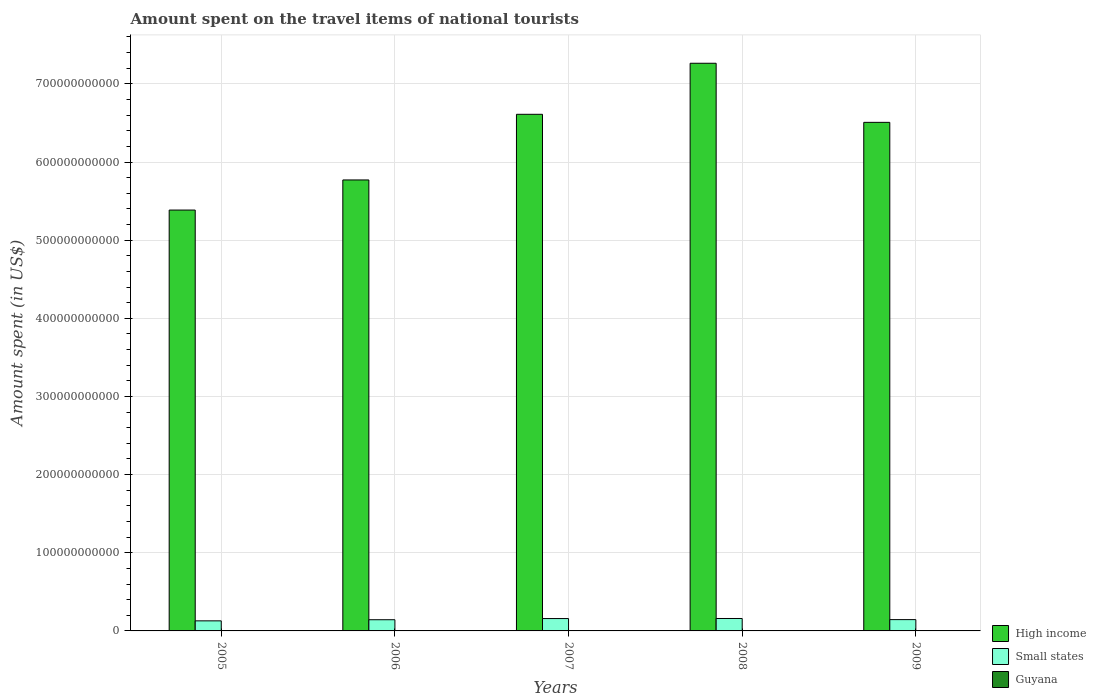How many different coloured bars are there?
Keep it short and to the point. 3. How many groups of bars are there?
Offer a terse response. 5. Are the number of bars per tick equal to the number of legend labels?
Your response must be concise. Yes. Are the number of bars on each tick of the X-axis equal?
Keep it short and to the point. Yes. How many bars are there on the 4th tick from the right?
Your response must be concise. 3. What is the amount spent on the travel items of national tourists in Guyana in 2009?
Offer a terse response. 3.50e+07. Across all years, what is the maximum amount spent on the travel items of national tourists in High income?
Offer a terse response. 7.26e+11. Across all years, what is the minimum amount spent on the travel items of national tourists in High income?
Ensure brevity in your answer.  5.39e+11. What is the total amount spent on the travel items of national tourists in High income in the graph?
Your answer should be very brief. 3.15e+12. What is the difference between the amount spent on the travel items of national tourists in Small states in 2007 and that in 2008?
Offer a very short reply. -7.92e+07. What is the difference between the amount spent on the travel items of national tourists in Small states in 2008 and the amount spent on the travel items of national tourists in Guyana in 2005?
Your response must be concise. 1.59e+1. What is the average amount spent on the travel items of national tourists in Small states per year?
Ensure brevity in your answer.  1.47e+1. In the year 2005, what is the difference between the amount spent on the travel items of national tourists in Small states and amount spent on the travel items of national tourists in Guyana?
Your answer should be very brief. 1.28e+1. What is the ratio of the amount spent on the travel items of national tourists in Guyana in 2005 to that in 2006?
Provide a succinct answer. 0.95. Is the difference between the amount spent on the travel items of national tourists in Small states in 2008 and 2009 greater than the difference between the amount spent on the travel items of national tourists in Guyana in 2008 and 2009?
Keep it short and to the point. Yes. What is the difference between the highest and the second highest amount spent on the travel items of national tourists in High income?
Your answer should be compact. 6.53e+1. What is the difference between the highest and the lowest amount spent on the travel items of national tourists in Guyana?
Your answer should be very brief. 2.40e+07. Is the sum of the amount spent on the travel items of national tourists in Small states in 2005 and 2008 greater than the maximum amount spent on the travel items of national tourists in High income across all years?
Offer a terse response. No. What does the 1st bar from the right in 2005 represents?
Keep it short and to the point. Guyana. How many bars are there?
Give a very brief answer. 15. What is the difference between two consecutive major ticks on the Y-axis?
Your response must be concise. 1.00e+11. Are the values on the major ticks of Y-axis written in scientific E-notation?
Provide a short and direct response. No. Does the graph contain grids?
Give a very brief answer. Yes. How many legend labels are there?
Your answer should be compact. 3. How are the legend labels stacked?
Give a very brief answer. Vertical. What is the title of the graph?
Make the answer very short. Amount spent on the travel items of national tourists. Does "Japan" appear as one of the legend labels in the graph?
Keep it short and to the point. No. What is the label or title of the Y-axis?
Provide a short and direct response. Amount spent (in US$). What is the Amount spent (in US$) in High income in 2005?
Make the answer very short. 5.39e+11. What is the Amount spent (in US$) in Small states in 2005?
Make the answer very short. 1.29e+1. What is the Amount spent (in US$) in Guyana in 2005?
Provide a succinct answer. 3.50e+07. What is the Amount spent (in US$) of High income in 2006?
Offer a terse response. 5.77e+11. What is the Amount spent (in US$) in Small states in 2006?
Your response must be concise. 1.43e+1. What is the Amount spent (in US$) of Guyana in 2006?
Provide a short and direct response. 3.70e+07. What is the Amount spent (in US$) in High income in 2007?
Offer a terse response. 6.61e+11. What is the Amount spent (in US$) of Small states in 2007?
Keep it short and to the point. 1.58e+1. What is the Amount spent (in US$) in High income in 2008?
Provide a short and direct response. 7.26e+11. What is the Amount spent (in US$) in Small states in 2008?
Provide a succinct answer. 1.59e+1. What is the Amount spent (in US$) in Guyana in 2008?
Your answer should be very brief. 5.90e+07. What is the Amount spent (in US$) in High income in 2009?
Your response must be concise. 6.51e+11. What is the Amount spent (in US$) of Small states in 2009?
Give a very brief answer. 1.45e+1. What is the Amount spent (in US$) in Guyana in 2009?
Offer a very short reply. 3.50e+07. Across all years, what is the maximum Amount spent (in US$) in High income?
Your response must be concise. 7.26e+11. Across all years, what is the maximum Amount spent (in US$) in Small states?
Give a very brief answer. 1.59e+1. Across all years, what is the maximum Amount spent (in US$) in Guyana?
Offer a terse response. 5.90e+07. Across all years, what is the minimum Amount spent (in US$) in High income?
Your answer should be compact. 5.39e+11. Across all years, what is the minimum Amount spent (in US$) in Small states?
Provide a succinct answer. 1.29e+1. Across all years, what is the minimum Amount spent (in US$) of Guyana?
Your answer should be very brief. 3.50e+07. What is the total Amount spent (in US$) in High income in the graph?
Offer a terse response. 3.15e+12. What is the total Amount spent (in US$) of Small states in the graph?
Your answer should be very brief. 7.34e+1. What is the total Amount spent (in US$) of Guyana in the graph?
Your answer should be very brief. 2.16e+08. What is the difference between the Amount spent (in US$) of High income in 2005 and that in 2006?
Your response must be concise. -3.85e+1. What is the difference between the Amount spent (in US$) of Small states in 2005 and that in 2006?
Give a very brief answer. -1.44e+09. What is the difference between the Amount spent (in US$) of High income in 2005 and that in 2007?
Your response must be concise. -1.23e+11. What is the difference between the Amount spent (in US$) in Small states in 2005 and that in 2007?
Offer a terse response. -2.95e+09. What is the difference between the Amount spent (in US$) in Guyana in 2005 and that in 2007?
Keep it short and to the point. -1.50e+07. What is the difference between the Amount spent (in US$) of High income in 2005 and that in 2008?
Your response must be concise. -1.88e+11. What is the difference between the Amount spent (in US$) in Small states in 2005 and that in 2008?
Provide a succinct answer. -3.02e+09. What is the difference between the Amount spent (in US$) of Guyana in 2005 and that in 2008?
Make the answer very short. -2.40e+07. What is the difference between the Amount spent (in US$) in High income in 2005 and that in 2009?
Your answer should be compact. -1.12e+11. What is the difference between the Amount spent (in US$) of Small states in 2005 and that in 2009?
Offer a terse response. -1.58e+09. What is the difference between the Amount spent (in US$) of High income in 2006 and that in 2007?
Your answer should be very brief. -8.40e+1. What is the difference between the Amount spent (in US$) of Small states in 2006 and that in 2007?
Make the answer very short. -1.51e+09. What is the difference between the Amount spent (in US$) in Guyana in 2006 and that in 2007?
Ensure brevity in your answer.  -1.30e+07. What is the difference between the Amount spent (in US$) in High income in 2006 and that in 2008?
Your answer should be very brief. -1.49e+11. What is the difference between the Amount spent (in US$) in Small states in 2006 and that in 2008?
Give a very brief answer. -1.59e+09. What is the difference between the Amount spent (in US$) of Guyana in 2006 and that in 2008?
Ensure brevity in your answer.  -2.20e+07. What is the difference between the Amount spent (in US$) of High income in 2006 and that in 2009?
Your answer should be compact. -7.37e+1. What is the difference between the Amount spent (in US$) in Small states in 2006 and that in 2009?
Make the answer very short. -1.39e+08. What is the difference between the Amount spent (in US$) in Guyana in 2006 and that in 2009?
Offer a very short reply. 2.00e+06. What is the difference between the Amount spent (in US$) in High income in 2007 and that in 2008?
Keep it short and to the point. -6.53e+1. What is the difference between the Amount spent (in US$) in Small states in 2007 and that in 2008?
Provide a succinct answer. -7.92e+07. What is the difference between the Amount spent (in US$) of Guyana in 2007 and that in 2008?
Your answer should be very brief. -9.00e+06. What is the difference between the Amount spent (in US$) of High income in 2007 and that in 2009?
Keep it short and to the point. 1.03e+1. What is the difference between the Amount spent (in US$) in Small states in 2007 and that in 2009?
Your response must be concise. 1.37e+09. What is the difference between the Amount spent (in US$) of Guyana in 2007 and that in 2009?
Your answer should be very brief. 1.50e+07. What is the difference between the Amount spent (in US$) of High income in 2008 and that in 2009?
Offer a terse response. 7.56e+1. What is the difference between the Amount spent (in US$) in Small states in 2008 and that in 2009?
Offer a very short reply. 1.45e+09. What is the difference between the Amount spent (in US$) of Guyana in 2008 and that in 2009?
Provide a short and direct response. 2.40e+07. What is the difference between the Amount spent (in US$) in High income in 2005 and the Amount spent (in US$) in Small states in 2006?
Make the answer very short. 5.24e+11. What is the difference between the Amount spent (in US$) in High income in 2005 and the Amount spent (in US$) in Guyana in 2006?
Offer a terse response. 5.39e+11. What is the difference between the Amount spent (in US$) of Small states in 2005 and the Amount spent (in US$) of Guyana in 2006?
Give a very brief answer. 1.28e+1. What is the difference between the Amount spent (in US$) in High income in 2005 and the Amount spent (in US$) in Small states in 2007?
Offer a terse response. 5.23e+11. What is the difference between the Amount spent (in US$) of High income in 2005 and the Amount spent (in US$) of Guyana in 2007?
Provide a succinct answer. 5.38e+11. What is the difference between the Amount spent (in US$) in Small states in 2005 and the Amount spent (in US$) in Guyana in 2007?
Provide a short and direct response. 1.28e+1. What is the difference between the Amount spent (in US$) of High income in 2005 and the Amount spent (in US$) of Small states in 2008?
Offer a terse response. 5.23e+11. What is the difference between the Amount spent (in US$) of High income in 2005 and the Amount spent (in US$) of Guyana in 2008?
Provide a succinct answer. 5.38e+11. What is the difference between the Amount spent (in US$) in Small states in 2005 and the Amount spent (in US$) in Guyana in 2008?
Your answer should be compact. 1.28e+1. What is the difference between the Amount spent (in US$) of High income in 2005 and the Amount spent (in US$) of Small states in 2009?
Offer a terse response. 5.24e+11. What is the difference between the Amount spent (in US$) in High income in 2005 and the Amount spent (in US$) in Guyana in 2009?
Make the answer very short. 5.39e+11. What is the difference between the Amount spent (in US$) of Small states in 2005 and the Amount spent (in US$) of Guyana in 2009?
Make the answer very short. 1.28e+1. What is the difference between the Amount spent (in US$) in High income in 2006 and the Amount spent (in US$) in Small states in 2007?
Make the answer very short. 5.61e+11. What is the difference between the Amount spent (in US$) of High income in 2006 and the Amount spent (in US$) of Guyana in 2007?
Ensure brevity in your answer.  5.77e+11. What is the difference between the Amount spent (in US$) of Small states in 2006 and the Amount spent (in US$) of Guyana in 2007?
Provide a short and direct response. 1.43e+1. What is the difference between the Amount spent (in US$) in High income in 2006 and the Amount spent (in US$) in Small states in 2008?
Your response must be concise. 5.61e+11. What is the difference between the Amount spent (in US$) in High income in 2006 and the Amount spent (in US$) in Guyana in 2008?
Your answer should be very brief. 5.77e+11. What is the difference between the Amount spent (in US$) in Small states in 2006 and the Amount spent (in US$) in Guyana in 2008?
Your response must be concise. 1.43e+1. What is the difference between the Amount spent (in US$) in High income in 2006 and the Amount spent (in US$) in Small states in 2009?
Keep it short and to the point. 5.63e+11. What is the difference between the Amount spent (in US$) of High income in 2006 and the Amount spent (in US$) of Guyana in 2009?
Your answer should be compact. 5.77e+11. What is the difference between the Amount spent (in US$) of Small states in 2006 and the Amount spent (in US$) of Guyana in 2009?
Keep it short and to the point. 1.43e+1. What is the difference between the Amount spent (in US$) in High income in 2007 and the Amount spent (in US$) in Small states in 2008?
Offer a terse response. 6.45e+11. What is the difference between the Amount spent (in US$) of High income in 2007 and the Amount spent (in US$) of Guyana in 2008?
Provide a short and direct response. 6.61e+11. What is the difference between the Amount spent (in US$) of Small states in 2007 and the Amount spent (in US$) of Guyana in 2008?
Keep it short and to the point. 1.58e+1. What is the difference between the Amount spent (in US$) in High income in 2007 and the Amount spent (in US$) in Small states in 2009?
Your answer should be compact. 6.47e+11. What is the difference between the Amount spent (in US$) in High income in 2007 and the Amount spent (in US$) in Guyana in 2009?
Make the answer very short. 6.61e+11. What is the difference between the Amount spent (in US$) of Small states in 2007 and the Amount spent (in US$) of Guyana in 2009?
Ensure brevity in your answer.  1.58e+1. What is the difference between the Amount spent (in US$) of High income in 2008 and the Amount spent (in US$) of Small states in 2009?
Your answer should be compact. 7.12e+11. What is the difference between the Amount spent (in US$) of High income in 2008 and the Amount spent (in US$) of Guyana in 2009?
Keep it short and to the point. 7.26e+11. What is the difference between the Amount spent (in US$) of Small states in 2008 and the Amount spent (in US$) of Guyana in 2009?
Make the answer very short. 1.59e+1. What is the average Amount spent (in US$) in High income per year?
Offer a terse response. 6.31e+11. What is the average Amount spent (in US$) in Small states per year?
Keep it short and to the point. 1.47e+1. What is the average Amount spent (in US$) in Guyana per year?
Make the answer very short. 4.32e+07. In the year 2005, what is the difference between the Amount spent (in US$) in High income and Amount spent (in US$) in Small states?
Keep it short and to the point. 5.26e+11. In the year 2005, what is the difference between the Amount spent (in US$) of High income and Amount spent (in US$) of Guyana?
Keep it short and to the point. 5.39e+11. In the year 2005, what is the difference between the Amount spent (in US$) in Small states and Amount spent (in US$) in Guyana?
Ensure brevity in your answer.  1.28e+1. In the year 2006, what is the difference between the Amount spent (in US$) of High income and Amount spent (in US$) of Small states?
Offer a very short reply. 5.63e+11. In the year 2006, what is the difference between the Amount spent (in US$) of High income and Amount spent (in US$) of Guyana?
Ensure brevity in your answer.  5.77e+11. In the year 2006, what is the difference between the Amount spent (in US$) in Small states and Amount spent (in US$) in Guyana?
Ensure brevity in your answer.  1.43e+1. In the year 2007, what is the difference between the Amount spent (in US$) in High income and Amount spent (in US$) in Small states?
Offer a terse response. 6.45e+11. In the year 2007, what is the difference between the Amount spent (in US$) of High income and Amount spent (in US$) of Guyana?
Your answer should be very brief. 6.61e+11. In the year 2007, what is the difference between the Amount spent (in US$) in Small states and Amount spent (in US$) in Guyana?
Make the answer very short. 1.58e+1. In the year 2008, what is the difference between the Amount spent (in US$) of High income and Amount spent (in US$) of Small states?
Your answer should be compact. 7.10e+11. In the year 2008, what is the difference between the Amount spent (in US$) of High income and Amount spent (in US$) of Guyana?
Ensure brevity in your answer.  7.26e+11. In the year 2008, what is the difference between the Amount spent (in US$) of Small states and Amount spent (in US$) of Guyana?
Offer a very short reply. 1.58e+1. In the year 2009, what is the difference between the Amount spent (in US$) of High income and Amount spent (in US$) of Small states?
Ensure brevity in your answer.  6.36e+11. In the year 2009, what is the difference between the Amount spent (in US$) of High income and Amount spent (in US$) of Guyana?
Your answer should be very brief. 6.51e+11. In the year 2009, what is the difference between the Amount spent (in US$) of Small states and Amount spent (in US$) of Guyana?
Give a very brief answer. 1.44e+1. What is the ratio of the Amount spent (in US$) in High income in 2005 to that in 2006?
Make the answer very short. 0.93. What is the ratio of the Amount spent (in US$) in Small states in 2005 to that in 2006?
Give a very brief answer. 0.9. What is the ratio of the Amount spent (in US$) of Guyana in 2005 to that in 2006?
Offer a terse response. 0.95. What is the ratio of the Amount spent (in US$) of High income in 2005 to that in 2007?
Offer a terse response. 0.81. What is the ratio of the Amount spent (in US$) in Small states in 2005 to that in 2007?
Give a very brief answer. 0.81. What is the ratio of the Amount spent (in US$) of Guyana in 2005 to that in 2007?
Provide a short and direct response. 0.7. What is the ratio of the Amount spent (in US$) in High income in 2005 to that in 2008?
Provide a short and direct response. 0.74. What is the ratio of the Amount spent (in US$) in Small states in 2005 to that in 2008?
Make the answer very short. 0.81. What is the ratio of the Amount spent (in US$) of Guyana in 2005 to that in 2008?
Offer a terse response. 0.59. What is the ratio of the Amount spent (in US$) of High income in 2005 to that in 2009?
Give a very brief answer. 0.83. What is the ratio of the Amount spent (in US$) in Small states in 2005 to that in 2009?
Your response must be concise. 0.89. What is the ratio of the Amount spent (in US$) in High income in 2006 to that in 2007?
Make the answer very short. 0.87. What is the ratio of the Amount spent (in US$) of Small states in 2006 to that in 2007?
Provide a short and direct response. 0.9. What is the ratio of the Amount spent (in US$) in Guyana in 2006 to that in 2007?
Give a very brief answer. 0.74. What is the ratio of the Amount spent (in US$) of High income in 2006 to that in 2008?
Your answer should be very brief. 0.79. What is the ratio of the Amount spent (in US$) in Small states in 2006 to that in 2008?
Provide a short and direct response. 0.9. What is the ratio of the Amount spent (in US$) of Guyana in 2006 to that in 2008?
Offer a terse response. 0.63. What is the ratio of the Amount spent (in US$) in High income in 2006 to that in 2009?
Provide a succinct answer. 0.89. What is the ratio of the Amount spent (in US$) of Guyana in 2006 to that in 2009?
Give a very brief answer. 1.06. What is the ratio of the Amount spent (in US$) in High income in 2007 to that in 2008?
Offer a terse response. 0.91. What is the ratio of the Amount spent (in US$) in Guyana in 2007 to that in 2008?
Offer a very short reply. 0.85. What is the ratio of the Amount spent (in US$) in High income in 2007 to that in 2009?
Provide a succinct answer. 1.02. What is the ratio of the Amount spent (in US$) in Small states in 2007 to that in 2009?
Your answer should be compact. 1.09. What is the ratio of the Amount spent (in US$) in Guyana in 2007 to that in 2009?
Your response must be concise. 1.43. What is the ratio of the Amount spent (in US$) of High income in 2008 to that in 2009?
Your answer should be compact. 1.12. What is the ratio of the Amount spent (in US$) in Small states in 2008 to that in 2009?
Offer a terse response. 1.1. What is the ratio of the Amount spent (in US$) in Guyana in 2008 to that in 2009?
Provide a succinct answer. 1.69. What is the difference between the highest and the second highest Amount spent (in US$) in High income?
Provide a short and direct response. 6.53e+1. What is the difference between the highest and the second highest Amount spent (in US$) in Small states?
Your response must be concise. 7.92e+07. What is the difference between the highest and the second highest Amount spent (in US$) of Guyana?
Give a very brief answer. 9.00e+06. What is the difference between the highest and the lowest Amount spent (in US$) in High income?
Offer a terse response. 1.88e+11. What is the difference between the highest and the lowest Amount spent (in US$) in Small states?
Offer a terse response. 3.02e+09. What is the difference between the highest and the lowest Amount spent (in US$) in Guyana?
Provide a short and direct response. 2.40e+07. 